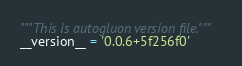Convert code to text. <code><loc_0><loc_0><loc_500><loc_500><_Python_>"""This is autogluon version file."""
__version__ = '0.0.6+5f256f0'
</code> 